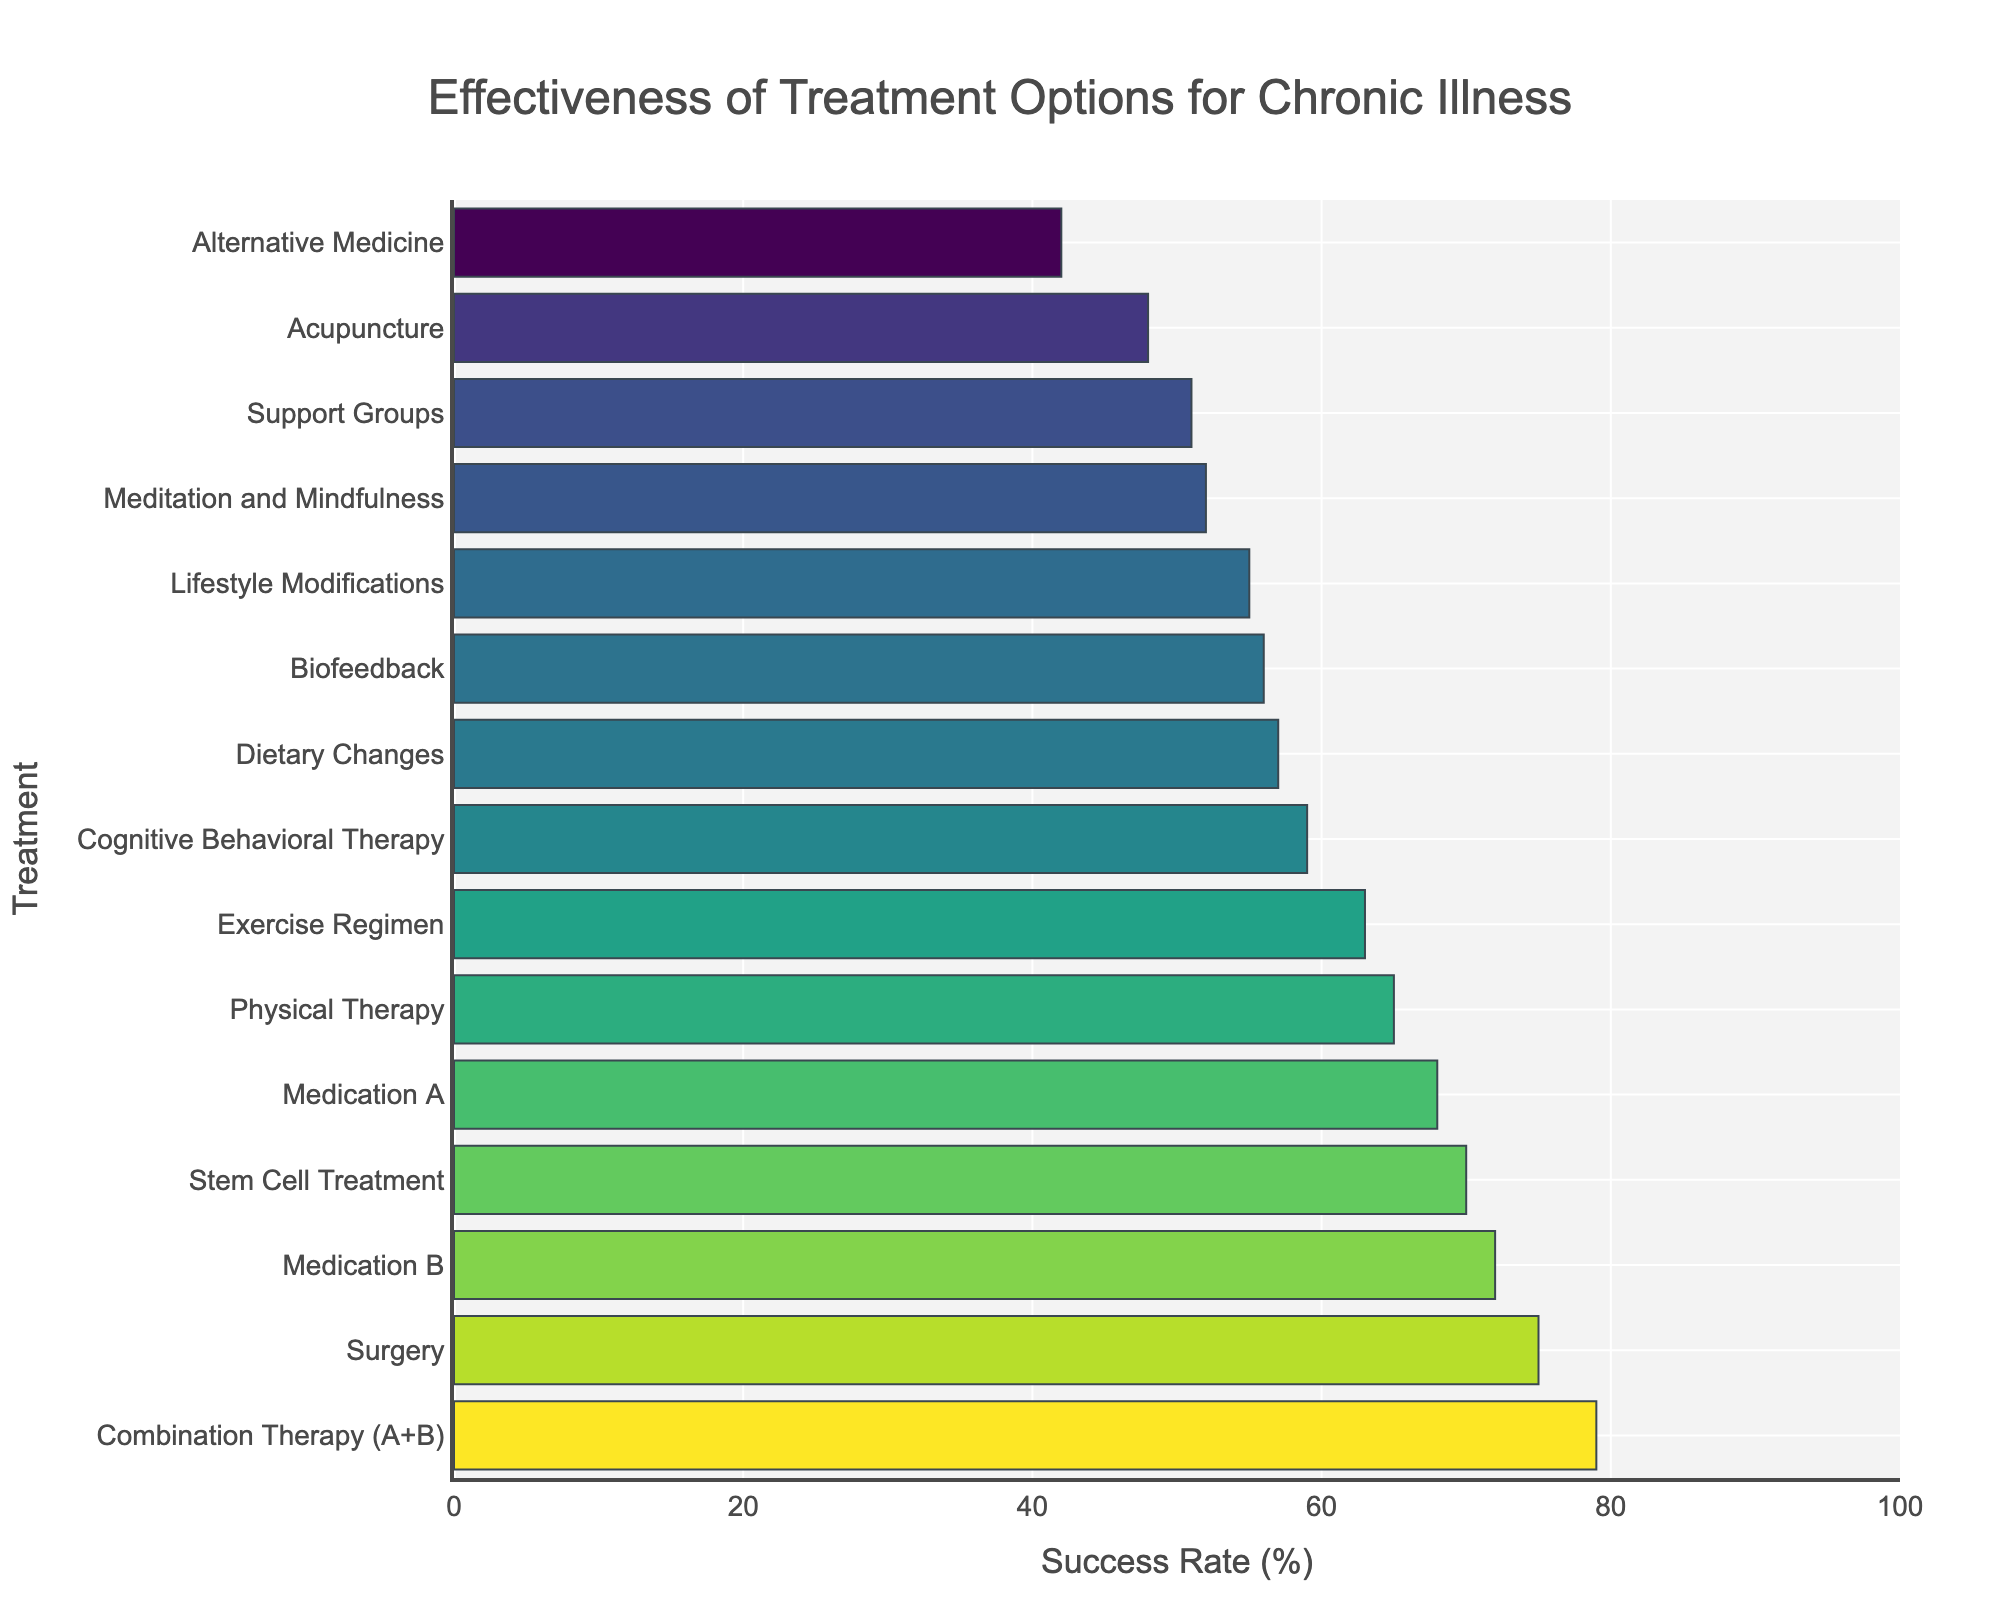What is the success rate of Combination Therapy (A+B)? Look at the figure to find the bar representing Combination Therapy (A+B) and check the success rate value shown next to it.
Answer: 79 Which treatment has the lowest success rate? Identify the shortest bar in the figure as it represents the treatment with the lowest success rate, labeled next to it.
Answer: Alternative Medicine Which treatment options have a success rate greater than 70%? Observe the bars that extend beyond the 70% mark and list the treatments associated with those bars.
Answer: Combination Therapy (A+B), Surgery What is the difference in success rate between Surgery and Medication A? Find the success rates for Surgery and Medication A from the figure. Calculate the difference: Surgery (75%) - Medication A (68%).
Answer: 7 What is the average success rate of Medication B, Physical Therapy, and Cognitive Behavioral Therapy? Find the success rates of Medication B, Physical Therapy, and Cognitive Behavioral Therapy (72%, 65%, 59%) in the figure, sum them up and divide by 3: (72 + 65 + 59) / 3 = 65.33.
Answer: 65.33 Which has a higher success rate, Dietary Changes or Biofeedback? Compare the heights of the bars representing Dietary Changes and Biofeedback to determine which is taller.
Answer: Biofeedback How much higher is the success rate of Stem Cell Treatment compared to Meditation and Mindfulness? Find the success rates for Stem Cell Treatment and Meditation and Mindfulness from the figure and calculate: Stem Cell Treatment (70%) - Meditation and Mindfulness (52%).
Answer: 18 Which treatments have a success rate between 50% and 60%? Identify the treatments with bars that fall between the 50% and 60% range.
Answer: Cognitive Behavioral Therapy, Lifestyle Modifications, Support Groups, Biofeedback, Dietary Changes What is the total success rate of the top three treatments? Identify the top three treatments with the highest success rates and sum their rates: Combination Therapy (A+B) (79%) + Surgery (75%) + Medication B (72%) = 226.
Answer: 226 Is there any treatment with a success rate of exactly 55%? Verify if any of the bars align with the 55% mark; check the label next to it.
Answer: Yes, Lifestyle Modifications 